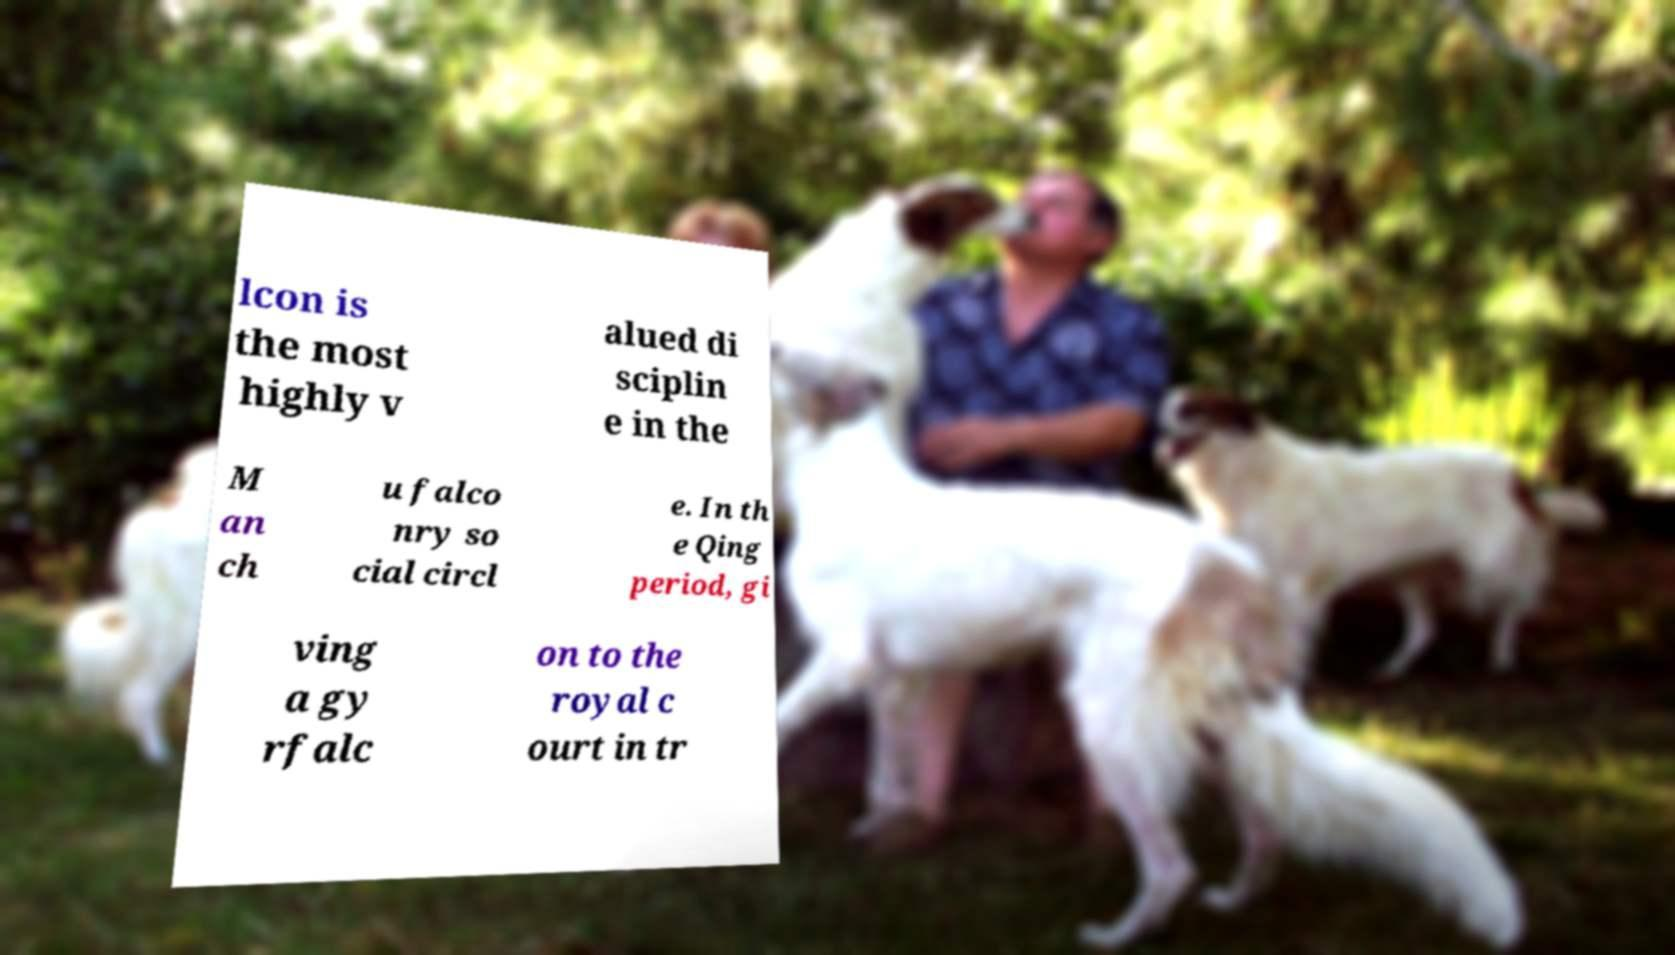What messages or text are displayed in this image? I need them in a readable, typed format. lcon is the most highly v alued di sciplin e in the M an ch u falco nry so cial circl e. In th e Qing period, gi ving a gy rfalc on to the royal c ourt in tr 